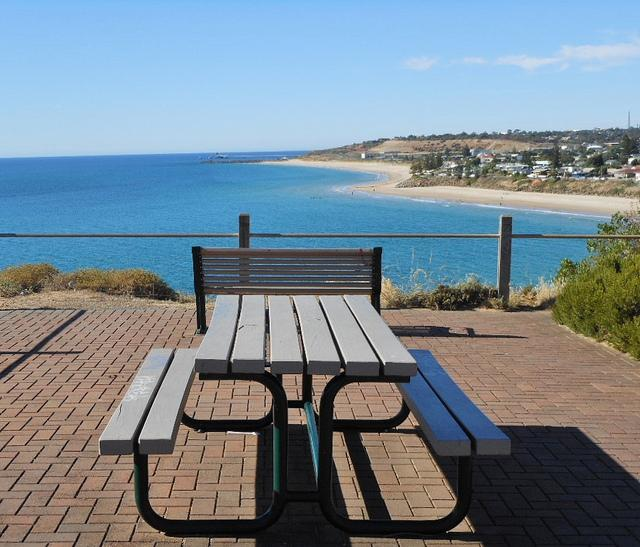What color is the top of the picnic bench painted all up like? Please explain your reasoning. gray. The top of the picnic bench is painted a light gray 